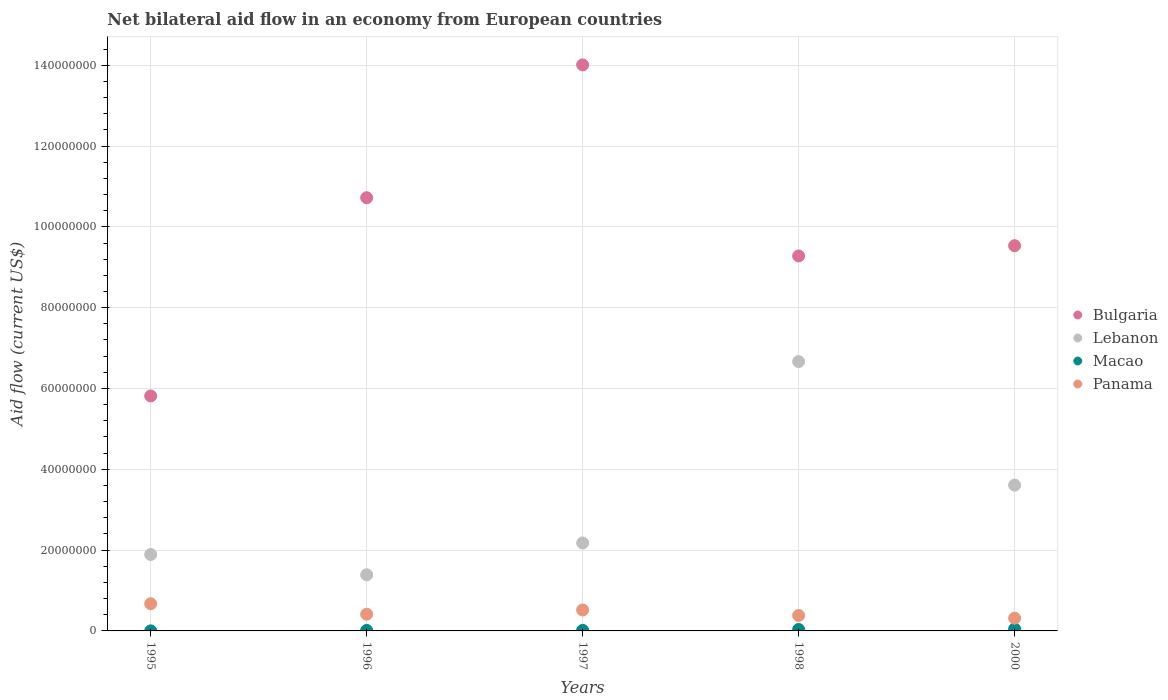Is the number of dotlines equal to the number of legend labels?
Provide a short and direct response. Yes. What is the net bilateral aid flow in Panama in 1998?
Offer a very short reply. 3.82e+06. Across all years, what is the maximum net bilateral aid flow in Bulgaria?
Offer a very short reply. 1.40e+08. Across all years, what is the minimum net bilateral aid flow in Lebanon?
Provide a short and direct response. 1.39e+07. What is the total net bilateral aid flow in Lebanon in the graph?
Give a very brief answer. 1.57e+08. What is the difference between the net bilateral aid flow in Macao in 1997 and that in 2000?
Offer a terse response. -3.50e+05. What is the difference between the net bilateral aid flow in Lebanon in 1997 and the net bilateral aid flow in Macao in 1995?
Keep it short and to the point. 2.18e+07. What is the average net bilateral aid flow in Lebanon per year?
Ensure brevity in your answer.  3.15e+07. In the year 1996, what is the difference between the net bilateral aid flow in Panama and net bilateral aid flow in Bulgaria?
Give a very brief answer. -1.03e+08. What is the ratio of the net bilateral aid flow in Panama in 1996 to that in 2000?
Provide a succinct answer. 1.31. What is the difference between the highest and the second highest net bilateral aid flow in Panama?
Offer a terse response. 1.55e+06. What is the difference between the highest and the lowest net bilateral aid flow in Bulgaria?
Provide a succinct answer. 8.19e+07. Is it the case that in every year, the sum of the net bilateral aid flow in Macao and net bilateral aid flow in Panama  is greater than the sum of net bilateral aid flow in Lebanon and net bilateral aid flow in Bulgaria?
Ensure brevity in your answer.  No. Is it the case that in every year, the sum of the net bilateral aid flow in Macao and net bilateral aid flow in Bulgaria  is greater than the net bilateral aid flow in Lebanon?
Provide a short and direct response. Yes. Is the net bilateral aid flow in Bulgaria strictly less than the net bilateral aid flow in Macao over the years?
Ensure brevity in your answer.  No. How many dotlines are there?
Your answer should be compact. 4. How many years are there in the graph?
Ensure brevity in your answer.  5. What is the difference between two consecutive major ticks on the Y-axis?
Your answer should be very brief. 2.00e+07. Does the graph contain grids?
Offer a terse response. Yes. Where does the legend appear in the graph?
Make the answer very short. Center right. How many legend labels are there?
Provide a succinct answer. 4. How are the legend labels stacked?
Provide a short and direct response. Vertical. What is the title of the graph?
Make the answer very short. Net bilateral aid flow in an economy from European countries. What is the label or title of the Y-axis?
Provide a succinct answer. Aid flow (current US$). What is the Aid flow (current US$) of Bulgaria in 1995?
Provide a succinct answer. 5.82e+07. What is the Aid flow (current US$) of Lebanon in 1995?
Offer a very short reply. 1.89e+07. What is the Aid flow (current US$) of Panama in 1995?
Keep it short and to the point. 6.73e+06. What is the Aid flow (current US$) of Bulgaria in 1996?
Ensure brevity in your answer.  1.07e+08. What is the Aid flow (current US$) of Lebanon in 1996?
Your response must be concise. 1.39e+07. What is the Aid flow (current US$) in Macao in 1996?
Make the answer very short. 1.30e+05. What is the Aid flow (current US$) of Panama in 1996?
Provide a succinct answer. 4.14e+06. What is the Aid flow (current US$) of Bulgaria in 1997?
Provide a succinct answer. 1.40e+08. What is the Aid flow (current US$) of Lebanon in 1997?
Make the answer very short. 2.18e+07. What is the Aid flow (current US$) of Panama in 1997?
Your answer should be compact. 5.18e+06. What is the Aid flow (current US$) of Bulgaria in 1998?
Give a very brief answer. 9.28e+07. What is the Aid flow (current US$) of Lebanon in 1998?
Provide a succinct answer. 6.67e+07. What is the Aid flow (current US$) of Panama in 1998?
Give a very brief answer. 3.82e+06. What is the Aid flow (current US$) in Bulgaria in 2000?
Your answer should be very brief. 9.53e+07. What is the Aid flow (current US$) of Lebanon in 2000?
Keep it short and to the point. 3.61e+07. What is the Aid flow (current US$) in Panama in 2000?
Provide a short and direct response. 3.16e+06. Across all years, what is the maximum Aid flow (current US$) in Bulgaria?
Keep it short and to the point. 1.40e+08. Across all years, what is the maximum Aid flow (current US$) of Lebanon?
Keep it short and to the point. 6.67e+07. Across all years, what is the maximum Aid flow (current US$) in Macao?
Your response must be concise. 4.90e+05. Across all years, what is the maximum Aid flow (current US$) in Panama?
Provide a short and direct response. 6.73e+06. Across all years, what is the minimum Aid flow (current US$) in Bulgaria?
Your response must be concise. 5.82e+07. Across all years, what is the minimum Aid flow (current US$) in Lebanon?
Your response must be concise. 1.39e+07. Across all years, what is the minimum Aid flow (current US$) of Macao?
Provide a succinct answer. 10000. Across all years, what is the minimum Aid flow (current US$) of Panama?
Your response must be concise. 3.16e+06. What is the total Aid flow (current US$) of Bulgaria in the graph?
Give a very brief answer. 4.94e+08. What is the total Aid flow (current US$) in Lebanon in the graph?
Make the answer very short. 1.57e+08. What is the total Aid flow (current US$) of Macao in the graph?
Your answer should be compact. 1.13e+06. What is the total Aid flow (current US$) in Panama in the graph?
Your answer should be compact. 2.30e+07. What is the difference between the Aid flow (current US$) in Bulgaria in 1995 and that in 1996?
Your answer should be compact. -4.91e+07. What is the difference between the Aid flow (current US$) of Lebanon in 1995 and that in 1996?
Provide a succinct answer. 5.03e+06. What is the difference between the Aid flow (current US$) in Macao in 1995 and that in 1996?
Give a very brief answer. -1.20e+05. What is the difference between the Aid flow (current US$) in Panama in 1995 and that in 1996?
Give a very brief answer. 2.59e+06. What is the difference between the Aid flow (current US$) of Bulgaria in 1995 and that in 1997?
Your answer should be compact. -8.19e+07. What is the difference between the Aid flow (current US$) in Lebanon in 1995 and that in 1997?
Offer a terse response. -2.85e+06. What is the difference between the Aid flow (current US$) of Panama in 1995 and that in 1997?
Give a very brief answer. 1.55e+06. What is the difference between the Aid flow (current US$) in Bulgaria in 1995 and that in 1998?
Your response must be concise. -3.46e+07. What is the difference between the Aid flow (current US$) in Lebanon in 1995 and that in 1998?
Keep it short and to the point. -4.77e+07. What is the difference between the Aid flow (current US$) of Macao in 1995 and that in 1998?
Your answer should be compact. -3.50e+05. What is the difference between the Aid flow (current US$) of Panama in 1995 and that in 1998?
Make the answer very short. 2.91e+06. What is the difference between the Aid flow (current US$) of Bulgaria in 1995 and that in 2000?
Make the answer very short. -3.72e+07. What is the difference between the Aid flow (current US$) in Lebanon in 1995 and that in 2000?
Your response must be concise. -1.72e+07. What is the difference between the Aid flow (current US$) in Macao in 1995 and that in 2000?
Provide a short and direct response. -4.80e+05. What is the difference between the Aid flow (current US$) of Panama in 1995 and that in 2000?
Ensure brevity in your answer.  3.57e+06. What is the difference between the Aid flow (current US$) in Bulgaria in 1996 and that in 1997?
Your answer should be compact. -3.29e+07. What is the difference between the Aid flow (current US$) in Lebanon in 1996 and that in 1997?
Your answer should be very brief. -7.88e+06. What is the difference between the Aid flow (current US$) in Macao in 1996 and that in 1997?
Keep it short and to the point. -10000. What is the difference between the Aid flow (current US$) of Panama in 1996 and that in 1997?
Provide a short and direct response. -1.04e+06. What is the difference between the Aid flow (current US$) in Bulgaria in 1996 and that in 1998?
Ensure brevity in your answer.  1.44e+07. What is the difference between the Aid flow (current US$) of Lebanon in 1996 and that in 1998?
Make the answer very short. -5.28e+07. What is the difference between the Aid flow (current US$) in Panama in 1996 and that in 1998?
Offer a terse response. 3.20e+05. What is the difference between the Aid flow (current US$) of Bulgaria in 1996 and that in 2000?
Your answer should be compact. 1.19e+07. What is the difference between the Aid flow (current US$) in Lebanon in 1996 and that in 2000?
Keep it short and to the point. -2.22e+07. What is the difference between the Aid flow (current US$) in Macao in 1996 and that in 2000?
Keep it short and to the point. -3.60e+05. What is the difference between the Aid flow (current US$) of Panama in 1996 and that in 2000?
Your response must be concise. 9.80e+05. What is the difference between the Aid flow (current US$) in Bulgaria in 1997 and that in 1998?
Provide a short and direct response. 4.73e+07. What is the difference between the Aid flow (current US$) of Lebanon in 1997 and that in 1998?
Ensure brevity in your answer.  -4.49e+07. What is the difference between the Aid flow (current US$) of Panama in 1997 and that in 1998?
Make the answer very short. 1.36e+06. What is the difference between the Aid flow (current US$) of Bulgaria in 1997 and that in 2000?
Your response must be concise. 4.48e+07. What is the difference between the Aid flow (current US$) of Lebanon in 1997 and that in 2000?
Your answer should be very brief. -1.43e+07. What is the difference between the Aid flow (current US$) in Macao in 1997 and that in 2000?
Provide a short and direct response. -3.50e+05. What is the difference between the Aid flow (current US$) of Panama in 1997 and that in 2000?
Make the answer very short. 2.02e+06. What is the difference between the Aid flow (current US$) of Bulgaria in 1998 and that in 2000?
Your response must be concise. -2.54e+06. What is the difference between the Aid flow (current US$) in Lebanon in 1998 and that in 2000?
Your response must be concise. 3.06e+07. What is the difference between the Aid flow (current US$) in Macao in 1998 and that in 2000?
Offer a very short reply. -1.30e+05. What is the difference between the Aid flow (current US$) of Panama in 1998 and that in 2000?
Give a very brief answer. 6.60e+05. What is the difference between the Aid flow (current US$) in Bulgaria in 1995 and the Aid flow (current US$) in Lebanon in 1996?
Ensure brevity in your answer.  4.43e+07. What is the difference between the Aid flow (current US$) in Bulgaria in 1995 and the Aid flow (current US$) in Macao in 1996?
Keep it short and to the point. 5.80e+07. What is the difference between the Aid flow (current US$) in Bulgaria in 1995 and the Aid flow (current US$) in Panama in 1996?
Keep it short and to the point. 5.40e+07. What is the difference between the Aid flow (current US$) in Lebanon in 1995 and the Aid flow (current US$) in Macao in 1996?
Ensure brevity in your answer.  1.88e+07. What is the difference between the Aid flow (current US$) of Lebanon in 1995 and the Aid flow (current US$) of Panama in 1996?
Ensure brevity in your answer.  1.48e+07. What is the difference between the Aid flow (current US$) of Macao in 1995 and the Aid flow (current US$) of Panama in 1996?
Provide a succinct answer. -4.13e+06. What is the difference between the Aid flow (current US$) of Bulgaria in 1995 and the Aid flow (current US$) of Lebanon in 1997?
Provide a succinct answer. 3.64e+07. What is the difference between the Aid flow (current US$) of Bulgaria in 1995 and the Aid flow (current US$) of Macao in 1997?
Provide a short and direct response. 5.80e+07. What is the difference between the Aid flow (current US$) of Bulgaria in 1995 and the Aid flow (current US$) of Panama in 1997?
Make the answer very short. 5.30e+07. What is the difference between the Aid flow (current US$) in Lebanon in 1995 and the Aid flow (current US$) in Macao in 1997?
Offer a very short reply. 1.88e+07. What is the difference between the Aid flow (current US$) in Lebanon in 1995 and the Aid flow (current US$) in Panama in 1997?
Ensure brevity in your answer.  1.37e+07. What is the difference between the Aid flow (current US$) of Macao in 1995 and the Aid flow (current US$) of Panama in 1997?
Your answer should be very brief. -5.17e+06. What is the difference between the Aid flow (current US$) in Bulgaria in 1995 and the Aid flow (current US$) in Lebanon in 1998?
Provide a succinct answer. -8.51e+06. What is the difference between the Aid flow (current US$) in Bulgaria in 1995 and the Aid flow (current US$) in Macao in 1998?
Your answer should be very brief. 5.78e+07. What is the difference between the Aid flow (current US$) of Bulgaria in 1995 and the Aid flow (current US$) of Panama in 1998?
Your answer should be very brief. 5.43e+07. What is the difference between the Aid flow (current US$) of Lebanon in 1995 and the Aid flow (current US$) of Macao in 1998?
Provide a short and direct response. 1.86e+07. What is the difference between the Aid flow (current US$) of Lebanon in 1995 and the Aid flow (current US$) of Panama in 1998?
Your answer should be very brief. 1.51e+07. What is the difference between the Aid flow (current US$) of Macao in 1995 and the Aid flow (current US$) of Panama in 1998?
Provide a succinct answer. -3.81e+06. What is the difference between the Aid flow (current US$) in Bulgaria in 1995 and the Aid flow (current US$) in Lebanon in 2000?
Your response must be concise. 2.21e+07. What is the difference between the Aid flow (current US$) in Bulgaria in 1995 and the Aid flow (current US$) in Macao in 2000?
Offer a terse response. 5.77e+07. What is the difference between the Aid flow (current US$) in Bulgaria in 1995 and the Aid flow (current US$) in Panama in 2000?
Provide a succinct answer. 5.50e+07. What is the difference between the Aid flow (current US$) of Lebanon in 1995 and the Aid flow (current US$) of Macao in 2000?
Offer a terse response. 1.84e+07. What is the difference between the Aid flow (current US$) of Lebanon in 1995 and the Aid flow (current US$) of Panama in 2000?
Your answer should be compact. 1.58e+07. What is the difference between the Aid flow (current US$) of Macao in 1995 and the Aid flow (current US$) of Panama in 2000?
Offer a very short reply. -3.15e+06. What is the difference between the Aid flow (current US$) of Bulgaria in 1996 and the Aid flow (current US$) of Lebanon in 1997?
Give a very brief answer. 8.54e+07. What is the difference between the Aid flow (current US$) of Bulgaria in 1996 and the Aid flow (current US$) of Macao in 1997?
Your answer should be very brief. 1.07e+08. What is the difference between the Aid flow (current US$) of Bulgaria in 1996 and the Aid flow (current US$) of Panama in 1997?
Make the answer very short. 1.02e+08. What is the difference between the Aid flow (current US$) in Lebanon in 1996 and the Aid flow (current US$) in Macao in 1997?
Keep it short and to the point. 1.38e+07. What is the difference between the Aid flow (current US$) of Lebanon in 1996 and the Aid flow (current US$) of Panama in 1997?
Give a very brief answer. 8.71e+06. What is the difference between the Aid flow (current US$) in Macao in 1996 and the Aid flow (current US$) in Panama in 1997?
Ensure brevity in your answer.  -5.05e+06. What is the difference between the Aid flow (current US$) of Bulgaria in 1996 and the Aid flow (current US$) of Lebanon in 1998?
Provide a succinct answer. 4.06e+07. What is the difference between the Aid flow (current US$) in Bulgaria in 1996 and the Aid flow (current US$) in Macao in 1998?
Your answer should be compact. 1.07e+08. What is the difference between the Aid flow (current US$) in Bulgaria in 1996 and the Aid flow (current US$) in Panama in 1998?
Keep it short and to the point. 1.03e+08. What is the difference between the Aid flow (current US$) of Lebanon in 1996 and the Aid flow (current US$) of Macao in 1998?
Your response must be concise. 1.35e+07. What is the difference between the Aid flow (current US$) of Lebanon in 1996 and the Aid flow (current US$) of Panama in 1998?
Your answer should be compact. 1.01e+07. What is the difference between the Aid flow (current US$) of Macao in 1996 and the Aid flow (current US$) of Panama in 1998?
Provide a succinct answer. -3.69e+06. What is the difference between the Aid flow (current US$) in Bulgaria in 1996 and the Aid flow (current US$) in Lebanon in 2000?
Keep it short and to the point. 7.11e+07. What is the difference between the Aid flow (current US$) of Bulgaria in 1996 and the Aid flow (current US$) of Macao in 2000?
Your answer should be compact. 1.07e+08. What is the difference between the Aid flow (current US$) of Bulgaria in 1996 and the Aid flow (current US$) of Panama in 2000?
Your answer should be very brief. 1.04e+08. What is the difference between the Aid flow (current US$) in Lebanon in 1996 and the Aid flow (current US$) in Macao in 2000?
Your answer should be very brief. 1.34e+07. What is the difference between the Aid flow (current US$) in Lebanon in 1996 and the Aid flow (current US$) in Panama in 2000?
Offer a terse response. 1.07e+07. What is the difference between the Aid flow (current US$) of Macao in 1996 and the Aid flow (current US$) of Panama in 2000?
Provide a short and direct response. -3.03e+06. What is the difference between the Aid flow (current US$) in Bulgaria in 1997 and the Aid flow (current US$) in Lebanon in 1998?
Give a very brief answer. 7.34e+07. What is the difference between the Aid flow (current US$) of Bulgaria in 1997 and the Aid flow (current US$) of Macao in 1998?
Ensure brevity in your answer.  1.40e+08. What is the difference between the Aid flow (current US$) in Bulgaria in 1997 and the Aid flow (current US$) in Panama in 1998?
Ensure brevity in your answer.  1.36e+08. What is the difference between the Aid flow (current US$) in Lebanon in 1997 and the Aid flow (current US$) in Macao in 1998?
Your answer should be compact. 2.14e+07. What is the difference between the Aid flow (current US$) in Lebanon in 1997 and the Aid flow (current US$) in Panama in 1998?
Ensure brevity in your answer.  1.80e+07. What is the difference between the Aid flow (current US$) of Macao in 1997 and the Aid flow (current US$) of Panama in 1998?
Provide a succinct answer. -3.68e+06. What is the difference between the Aid flow (current US$) of Bulgaria in 1997 and the Aid flow (current US$) of Lebanon in 2000?
Provide a short and direct response. 1.04e+08. What is the difference between the Aid flow (current US$) of Bulgaria in 1997 and the Aid flow (current US$) of Macao in 2000?
Make the answer very short. 1.40e+08. What is the difference between the Aid flow (current US$) of Bulgaria in 1997 and the Aid flow (current US$) of Panama in 2000?
Keep it short and to the point. 1.37e+08. What is the difference between the Aid flow (current US$) of Lebanon in 1997 and the Aid flow (current US$) of Macao in 2000?
Keep it short and to the point. 2.13e+07. What is the difference between the Aid flow (current US$) of Lebanon in 1997 and the Aid flow (current US$) of Panama in 2000?
Your answer should be very brief. 1.86e+07. What is the difference between the Aid flow (current US$) in Macao in 1997 and the Aid flow (current US$) in Panama in 2000?
Provide a short and direct response. -3.02e+06. What is the difference between the Aid flow (current US$) of Bulgaria in 1998 and the Aid flow (current US$) of Lebanon in 2000?
Offer a very short reply. 5.67e+07. What is the difference between the Aid flow (current US$) of Bulgaria in 1998 and the Aid flow (current US$) of Macao in 2000?
Make the answer very short. 9.23e+07. What is the difference between the Aid flow (current US$) of Bulgaria in 1998 and the Aid flow (current US$) of Panama in 2000?
Your response must be concise. 8.96e+07. What is the difference between the Aid flow (current US$) in Lebanon in 1998 and the Aid flow (current US$) in Macao in 2000?
Offer a very short reply. 6.62e+07. What is the difference between the Aid flow (current US$) of Lebanon in 1998 and the Aid flow (current US$) of Panama in 2000?
Offer a terse response. 6.35e+07. What is the difference between the Aid flow (current US$) of Macao in 1998 and the Aid flow (current US$) of Panama in 2000?
Provide a short and direct response. -2.80e+06. What is the average Aid flow (current US$) in Bulgaria per year?
Ensure brevity in your answer.  9.87e+07. What is the average Aid flow (current US$) in Lebanon per year?
Provide a short and direct response. 3.15e+07. What is the average Aid flow (current US$) in Macao per year?
Your response must be concise. 2.26e+05. What is the average Aid flow (current US$) of Panama per year?
Your response must be concise. 4.61e+06. In the year 1995, what is the difference between the Aid flow (current US$) of Bulgaria and Aid flow (current US$) of Lebanon?
Offer a very short reply. 3.92e+07. In the year 1995, what is the difference between the Aid flow (current US$) in Bulgaria and Aid flow (current US$) in Macao?
Your answer should be very brief. 5.81e+07. In the year 1995, what is the difference between the Aid flow (current US$) in Bulgaria and Aid flow (current US$) in Panama?
Your response must be concise. 5.14e+07. In the year 1995, what is the difference between the Aid flow (current US$) of Lebanon and Aid flow (current US$) of Macao?
Ensure brevity in your answer.  1.89e+07. In the year 1995, what is the difference between the Aid flow (current US$) in Lebanon and Aid flow (current US$) in Panama?
Keep it short and to the point. 1.22e+07. In the year 1995, what is the difference between the Aid flow (current US$) of Macao and Aid flow (current US$) of Panama?
Keep it short and to the point. -6.72e+06. In the year 1996, what is the difference between the Aid flow (current US$) of Bulgaria and Aid flow (current US$) of Lebanon?
Ensure brevity in your answer.  9.33e+07. In the year 1996, what is the difference between the Aid flow (current US$) in Bulgaria and Aid flow (current US$) in Macao?
Your response must be concise. 1.07e+08. In the year 1996, what is the difference between the Aid flow (current US$) in Bulgaria and Aid flow (current US$) in Panama?
Provide a succinct answer. 1.03e+08. In the year 1996, what is the difference between the Aid flow (current US$) of Lebanon and Aid flow (current US$) of Macao?
Make the answer very short. 1.38e+07. In the year 1996, what is the difference between the Aid flow (current US$) in Lebanon and Aid flow (current US$) in Panama?
Provide a short and direct response. 9.75e+06. In the year 1996, what is the difference between the Aid flow (current US$) of Macao and Aid flow (current US$) of Panama?
Keep it short and to the point. -4.01e+06. In the year 1997, what is the difference between the Aid flow (current US$) of Bulgaria and Aid flow (current US$) of Lebanon?
Keep it short and to the point. 1.18e+08. In the year 1997, what is the difference between the Aid flow (current US$) of Bulgaria and Aid flow (current US$) of Macao?
Make the answer very short. 1.40e+08. In the year 1997, what is the difference between the Aid flow (current US$) of Bulgaria and Aid flow (current US$) of Panama?
Give a very brief answer. 1.35e+08. In the year 1997, what is the difference between the Aid flow (current US$) in Lebanon and Aid flow (current US$) in Macao?
Provide a succinct answer. 2.16e+07. In the year 1997, what is the difference between the Aid flow (current US$) in Lebanon and Aid flow (current US$) in Panama?
Provide a short and direct response. 1.66e+07. In the year 1997, what is the difference between the Aid flow (current US$) of Macao and Aid flow (current US$) of Panama?
Your response must be concise. -5.04e+06. In the year 1998, what is the difference between the Aid flow (current US$) in Bulgaria and Aid flow (current US$) in Lebanon?
Keep it short and to the point. 2.61e+07. In the year 1998, what is the difference between the Aid flow (current US$) in Bulgaria and Aid flow (current US$) in Macao?
Make the answer very short. 9.24e+07. In the year 1998, what is the difference between the Aid flow (current US$) in Bulgaria and Aid flow (current US$) in Panama?
Provide a short and direct response. 8.90e+07. In the year 1998, what is the difference between the Aid flow (current US$) in Lebanon and Aid flow (current US$) in Macao?
Provide a succinct answer. 6.63e+07. In the year 1998, what is the difference between the Aid flow (current US$) of Lebanon and Aid flow (current US$) of Panama?
Your answer should be compact. 6.28e+07. In the year 1998, what is the difference between the Aid flow (current US$) in Macao and Aid flow (current US$) in Panama?
Your response must be concise. -3.46e+06. In the year 2000, what is the difference between the Aid flow (current US$) in Bulgaria and Aid flow (current US$) in Lebanon?
Offer a terse response. 5.93e+07. In the year 2000, what is the difference between the Aid flow (current US$) of Bulgaria and Aid flow (current US$) of Macao?
Keep it short and to the point. 9.48e+07. In the year 2000, what is the difference between the Aid flow (current US$) in Bulgaria and Aid flow (current US$) in Panama?
Keep it short and to the point. 9.22e+07. In the year 2000, what is the difference between the Aid flow (current US$) of Lebanon and Aid flow (current US$) of Macao?
Keep it short and to the point. 3.56e+07. In the year 2000, what is the difference between the Aid flow (current US$) in Lebanon and Aid flow (current US$) in Panama?
Provide a short and direct response. 3.29e+07. In the year 2000, what is the difference between the Aid flow (current US$) of Macao and Aid flow (current US$) of Panama?
Ensure brevity in your answer.  -2.67e+06. What is the ratio of the Aid flow (current US$) of Bulgaria in 1995 to that in 1996?
Your answer should be very brief. 0.54. What is the ratio of the Aid flow (current US$) in Lebanon in 1995 to that in 1996?
Your response must be concise. 1.36. What is the ratio of the Aid flow (current US$) of Macao in 1995 to that in 1996?
Your answer should be compact. 0.08. What is the ratio of the Aid flow (current US$) of Panama in 1995 to that in 1996?
Provide a short and direct response. 1.63. What is the ratio of the Aid flow (current US$) in Bulgaria in 1995 to that in 1997?
Offer a terse response. 0.42. What is the ratio of the Aid flow (current US$) in Lebanon in 1995 to that in 1997?
Keep it short and to the point. 0.87. What is the ratio of the Aid flow (current US$) of Macao in 1995 to that in 1997?
Your answer should be very brief. 0.07. What is the ratio of the Aid flow (current US$) in Panama in 1995 to that in 1997?
Your answer should be very brief. 1.3. What is the ratio of the Aid flow (current US$) in Bulgaria in 1995 to that in 1998?
Your answer should be compact. 0.63. What is the ratio of the Aid flow (current US$) in Lebanon in 1995 to that in 1998?
Make the answer very short. 0.28. What is the ratio of the Aid flow (current US$) of Macao in 1995 to that in 1998?
Your response must be concise. 0.03. What is the ratio of the Aid flow (current US$) in Panama in 1995 to that in 1998?
Keep it short and to the point. 1.76. What is the ratio of the Aid flow (current US$) of Bulgaria in 1995 to that in 2000?
Provide a short and direct response. 0.61. What is the ratio of the Aid flow (current US$) of Lebanon in 1995 to that in 2000?
Provide a succinct answer. 0.52. What is the ratio of the Aid flow (current US$) of Macao in 1995 to that in 2000?
Provide a succinct answer. 0.02. What is the ratio of the Aid flow (current US$) of Panama in 1995 to that in 2000?
Offer a terse response. 2.13. What is the ratio of the Aid flow (current US$) in Bulgaria in 1996 to that in 1997?
Give a very brief answer. 0.77. What is the ratio of the Aid flow (current US$) in Lebanon in 1996 to that in 1997?
Ensure brevity in your answer.  0.64. What is the ratio of the Aid flow (current US$) in Panama in 1996 to that in 1997?
Provide a short and direct response. 0.8. What is the ratio of the Aid flow (current US$) in Bulgaria in 1996 to that in 1998?
Your response must be concise. 1.16. What is the ratio of the Aid flow (current US$) of Lebanon in 1996 to that in 1998?
Your answer should be compact. 0.21. What is the ratio of the Aid flow (current US$) in Macao in 1996 to that in 1998?
Your response must be concise. 0.36. What is the ratio of the Aid flow (current US$) in Panama in 1996 to that in 1998?
Your answer should be compact. 1.08. What is the ratio of the Aid flow (current US$) of Bulgaria in 1996 to that in 2000?
Give a very brief answer. 1.12. What is the ratio of the Aid flow (current US$) in Lebanon in 1996 to that in 2000?
Ensure brevity in your answer.  0.39. What is the ratio of the Aid flow (current US$) of Macao in 1996 to that in 2000?
Your answer should be compact. 0.27. What is the ratio of the Aid flow (current US$) of Panama in 1996 to that in 2000?
Give a very brief answer. 1.31. What is the ratio of the Aid flow (current US$) of Bulgaria in 1997 to that in 1998?
Ensure brevity in your answer.  1.51. What is the ratio of the Aid flow (current US$) in Lebanon in 1997 to that in 1998?
Offer a terse response. 0.33. What is the ratio of the Aid flow (current US$) of Macao in 1997 to that in 1998?
Offer a terse response. 0.39. What is the ratio of the Aid flow (current US$) in Panama in 1997 to that in 1998?
Provide a short and direct response. 1.36. What is the ratio of the Aid flow (current US$) of Bulgaria in 1997 to that in 2000?
Make the answer very short. 1.47. What is the ratio of the Aid flow (current US$) in Lebanon in 1997 to that in 2000?
Make the answer very short. 0.6. What is the ratio of the Aid flow (current US$) of Macao in 1997 to that in 2000?
Provide a succinct answer. 0.29. What is the ratio of the Aid flow (current US$) in Panama in 1997 to that in 2000?
Keep it short and to the point. 1.64. What is the ratio of the Aid flow (current US$) in Bulgaria in 1998 to that in 2000?
Your answer should be compact. 0.97. What is the ratio of the Aid flow (current US$) in Lebanon in 1998 to that in 2000?
Your answer should be very brief. 1.85. What is the ratio of the Aid flow (current US$) of Macao in 1998 to that in 2000?
Your response must be concise. 0.73. What is the ratio of the Aid flow (current US$) of Panama in 1998 to that in 2000?
Give a very brief answer. 1.21. What is the difference between the highest and the second highest Aid flow (current US$) of Bulgaria?
Provide a succinct answer. 3.29e+07. What is the difference between the highest and the second highest Aid flow (current US$) in Lebanon?
Your answer should be compact. 3.06e+07. What is the difference between the highest and the second highest Aid flow (current US$) in Macao?
Your response must be concise. 1.30e+05. What is the difference between the highest and the second highest Aid flow (current US$) in Panama?
Give a very brief answer. 1.55e+06. What is the difference between the highest and the lowest Aid flow (current US$) in Bulgaria?
Provide a short and direct response. 8.19e+07. What is the difference between the highest and the lowest Aid flow (current US$) of Lebanon?
Keep it short and to the point. 5.28e+07. What is the difference between the highest and the lowest Aid flow (current US$) of Macao?
Your answer should be compact. 4.80e+05. What is the difference between the highest and the lowest Aid flow (current US$) of Panama?
Provide a short and direct response. 3.57e+06. 